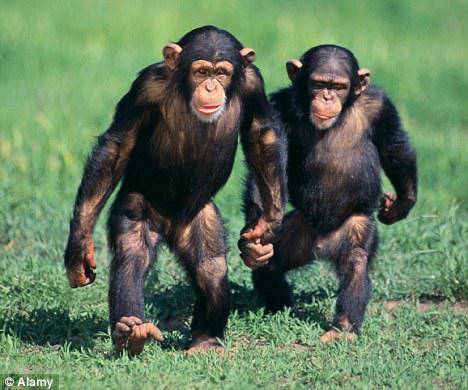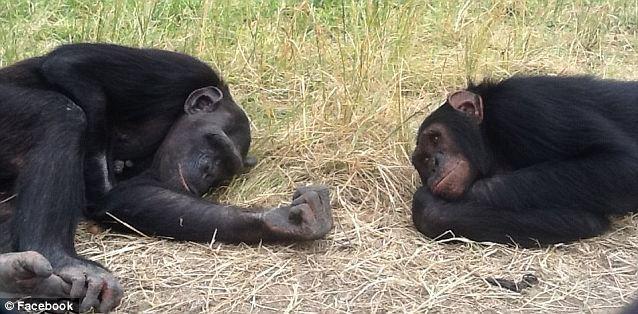The first image is the image on the left, the second image is the image on the right. Given the left and right images, does the statement "An image shows a pair of same-sized chimps in a hugging pose." hold true? Answer yes or no. No. The first image is the image on the left, the second image is the image on the right. Considering the images on both sides, is "There is two chimpanzees in the right image laying down." valid? Answer yes or no. Yes. 